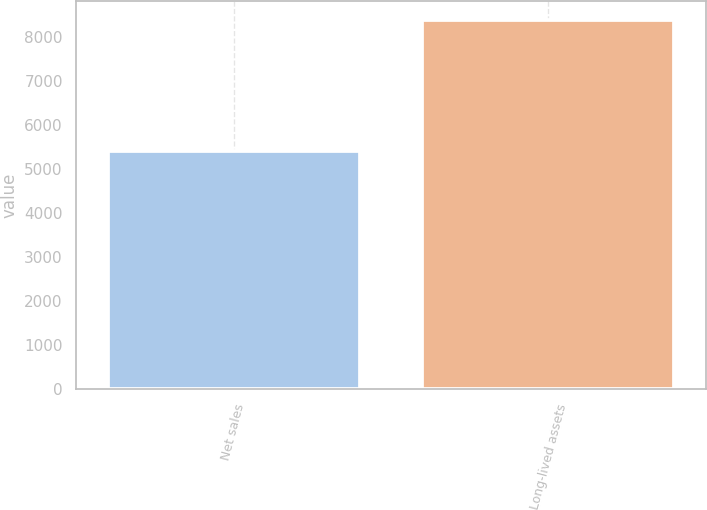Convert chart to OTSL. <chart><loc_0><loc_0><loc_500><loc_500><bar_chart><fcel>Net sales<fcel>Long-lived assets<nl><fcel>5408.9<fcel>8386.3<nl></chart> 